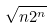Convert formula to latex. <formula><loc_0><loc_0><loc_500><loc_500>\sqrt { n 2 ^ { n } }</formula> 